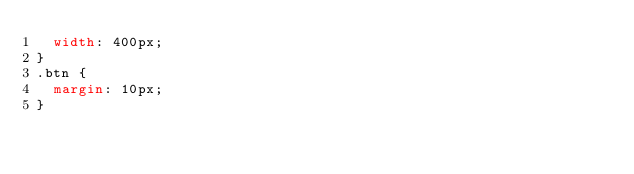<code> <loc_0><loc_0><loc_500><loc_500><_CSS_>  width: 400px;
}
.btn {
  margin: 10px;
}
</code> 